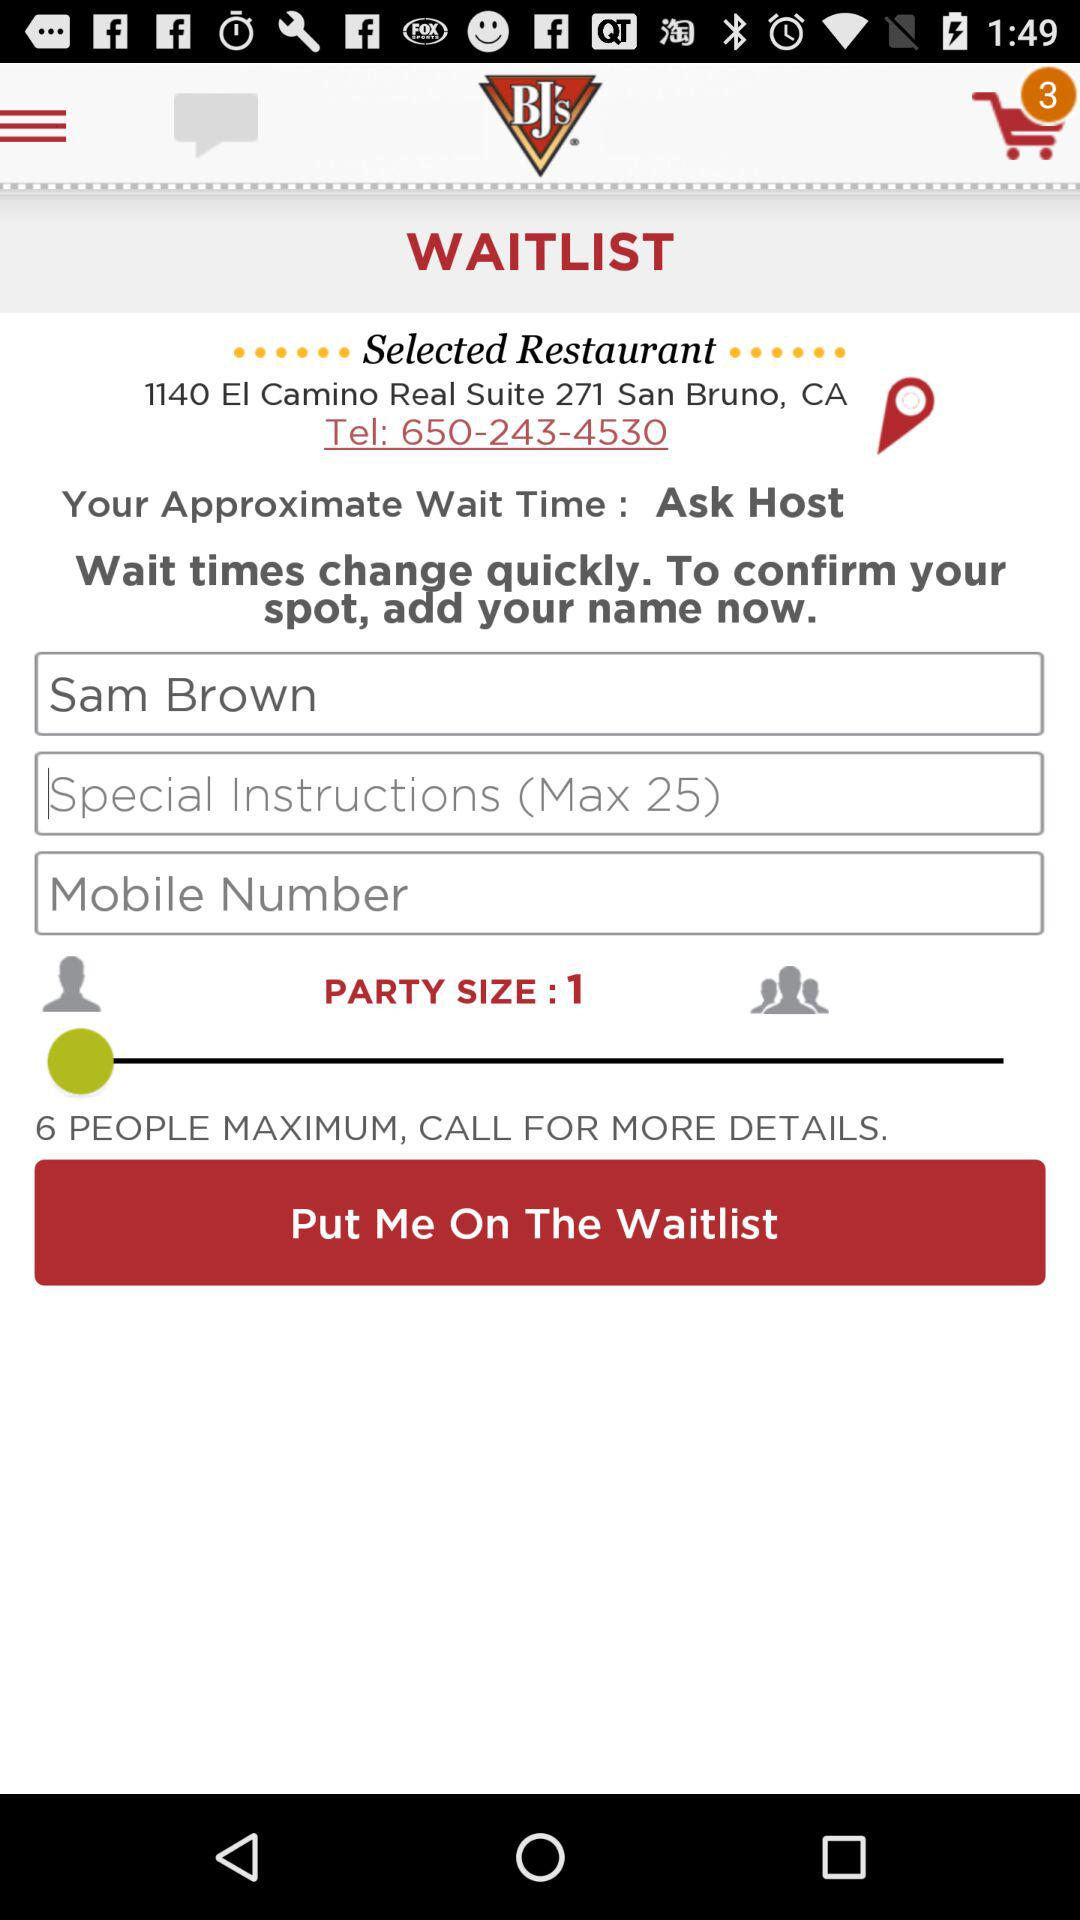What is the upper limit for special instructions? The upper limit for special instructions is 25. 